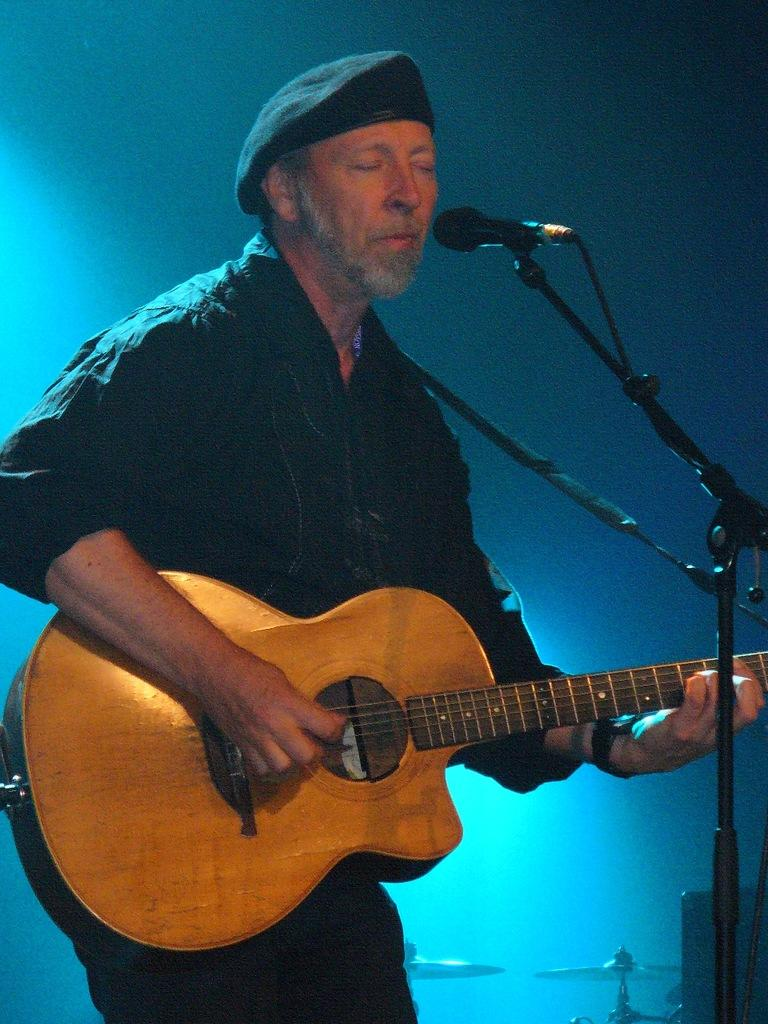What is the man in the image wearing? The man is wearing black attire and a black cap. What is the man doing in the image? The man is standing in front of a microphone and playing a guitar. What other musical instruments can be seen in the image? There are cymbals and other musical instruments in the image. What type of stone is the man using as a guitar pick in the image? There is no stone visible in the image, and the man is not using a stone as a guitar pick. 